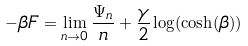<formula> <loc_0><loc_0><loc_500><loc_500>- \beta F = \lim _ { n \to 0 } \frac { \Psi _ { n } } { n } + \frac { \gamma } { 2 } \log ( \cosh ( \beta ) )</formula> 